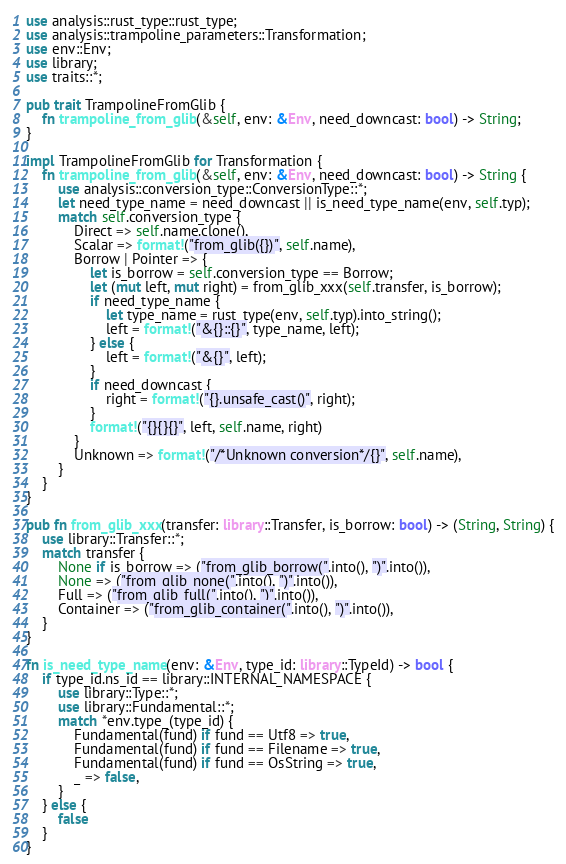<code> <loc_0><loc_0><loc_500><loc_500><_Rust_>use analysis::rust_type::rust_type;
use analysis::trampoline_parameters::Transformation;
use env::Env;
use library;
use traits::*;

pub trait TrampolineFromGlib {
    fn trampoline_from_glib(&self, env: &Env, need_downcast: bool) -> String;
}

impl TrampolineFromGlib for Transformation {
    fn trampoline_from_glib(&self, env: &Env, need_downcast: bool) -> String {
        use analysis::conversion_type::ConversionType::*;
        let need_type_name = need_downcast || is_need_type_name(env, self.typ);
        match self.conversion_type {
            Direct => self.name.clone(),
            Scalar => format!("from_glib({})", self.name),
            Borrow | Pointer => {
                let is_borrow = self.conversion_type == Borrow;
                let (mut left, mut right) = from_glib_xxx(self.transfer, is_borrow);
                if need_type_name {
                    let type_name = rust_type(env, self.typ).into_string();
                    left = format!("&{}::{}", type_name, left);
                } else {
                    left = format!("&{}", left);
                }
                if need_downcast {
                    right = format!("{}.unsafe_cast()", right);
                }
                format!("{}{}{}", left, self.name, right)
            }
            Unknown => format!("/*Unknown conversion*/{}", self.name),
        }
    }
}

pub fn from_glib_xxx(transfer: library::Transfer, is_borrow: bool) -> (String, String) {
    use library::Transfer::*;
    match transfer {
        None if is_borrow => ("from_glib_borrow(".into(), ")".into()),
        None => ("from_glib_none(".into(), ")".into()),
        Full => ("from_glib_full(".into(), ")".into()),
        Container => ("from_glib_container(".into(), ")".into()),
    }
}

fn is_need_type_name(env: &Env, type_id: library::TypeId) -> bool {
    if type_id.ns_id == library::INTERNAL_NAMESPACE {
        use library::Type::*;
        use library::Fundamental::*;
        match *env.type_(type_id) {
            Fundamental(fund) if fund == Utf8 => true,
            Fundamental(fund) if fund == Filename => true,
            Fundamental(fund) if fund == OsString => true,
            _ => false,
        }
    } else {
        false
    }
}
</code> 